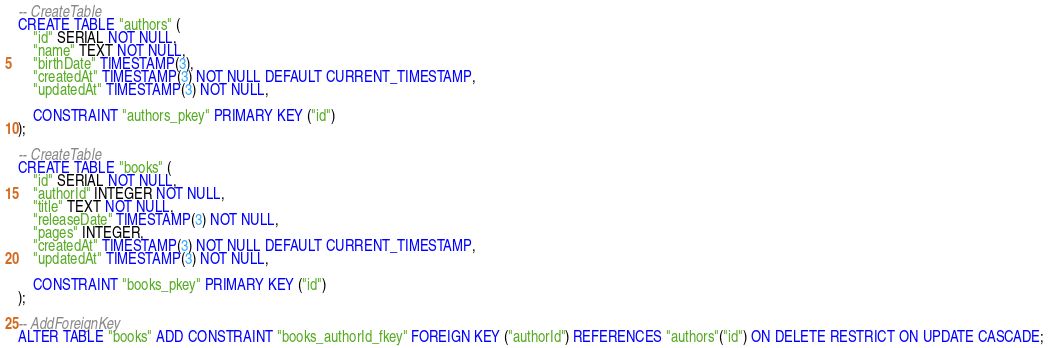Convert code to text. <code><loc_0><loc_0><loc_500><loc_500><_SQL_>-- CreateTable
CREATE TABLE "authors" (
    "id" SERIAL NOT NULL,
    "name" TEXT NOT NULL,
    "birthDate" TIMESTAMP(3),
    "createdAt" TIMESTAMP(3) NOT NULL DEFAULT CURRENT_TIMESTAMP,
    "updatedAt" TIMESTAMP(3) NOT NULL,

    CONSTRAINT "authors_pkey" PRIMARY KEY ("id")
);

-- CreateTable
CREATE TABLE "books" (
    "id" SERIAL NOT NULL,
    "authorId" INTEGER NOT NULL,
    "title" TEXT NOT NULL,
    "releaseDate" TIMESTAMP(3) NOT NULL,
    "pages" INTEGER,
    "createdAt" TIMESTAMP(3) NOT NULL DEFAULT CURRENT_TIMESTAMP,
    "updatedAt" TIMESTAMP(3) NOT NULL,

    CONSTRAINT "books_pkey" PRIMARY KEY ("id")
);

-- AddForeignKey
ALTER TABLE "books" ADD CONSTRAINT "books_authorId_fkey" FOREIGN KEY ("authorId") REFERENCES "authors"("id") ON DELETE RESTRICT ON UPDATE CASCADE;
</code> 